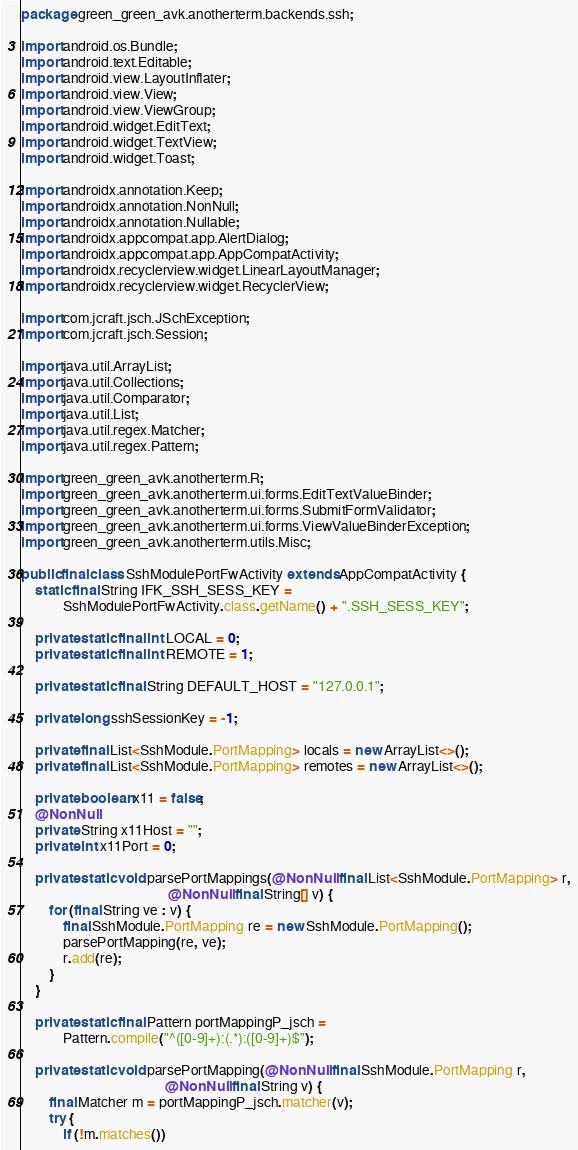<code> <loc_0><loc_0><loc_500><loc_500><_Java_>package green_green_avk.anotherterm.backends.ssh;

import android.os.Bundle;
import android.text.Editable;
import android.view.LayoutInflater;
import android.view.View;
import android.view.ViewGroup;
import android.widget.EditText;
import android.widget.TextView;
import android.widget.Toast;

import androidx.annotation.Keep;
import androidx.annotation.NonNull;
import androidx.annotation.Nullable;
import androidx.appcompat.app.AlertDialog;
import androidx.appcompat.app.AppCompatActivity;
import androidx.recyclerview.widget.LinearLayoutManager;
import androidx.recyclerview.widget.RecyclerView;

import com.jcraft.jsch.JSchException;
import com.jcraft.jsch.Session;

import java.util.ArrayList;
import java.util.Collections;
import java.util.Comparator;
import java.util.List;
import java.util.regex.Matcher;
import java.util.regex.Pattern;

import green_green_avk.anotherterm.R;
import green_green_avk.anotherterm.ui.forms.EditTextValueBinder;
import green_green_avk.anotherterm.ui.forms.SubmitFormValidator;
import green_green_avk.anotherterm.ui.forms.ViewValueBinderException;
import green_green_avk.anotherterm.utils.Misc;

public final class SshModulePortFwActivity extends AppCompatActivity {
    static final String IFK_SSH_SESS_KEY =
            SshModulePortFwActivity.class.getName() + ".SSH_SESS_KEY";

    private static final int LOCAL = 0;
    private static final int REMOTE = 1;

    private static final String DEFAULT_HOST = "127.0.0.1";

    private long sshSessionKey = -1;

    private final List<SshModule.PortMapping> locals = new ArrayList<>();
    private final List<SshModule.PortMapping> remotes = new ArrayList<>();

    private boolean x11 = false;
    @NonNull
    private String x11Host = "";
    private int x11Port = 0;

    private static void parsePortMappings(@NonNull final List<SshModule.PortMapping> r,
                                          @NonNull final String[] v) {
        for (final String ve : v) {
            final SshModule.PortMapping re = new SshModule.PortMapping();
            parsePortMapping(re, ve);
            r.add(re);
        }
    }

    private static final Pattern portMappingP_jsch =
            Pattern.compile("^([0-9]+):(.*):([0-9]+)$");

    private static void parsePortMapping(@NonNull final SshModule.PortMapping r,
                                         @NonNull final String v) {
        final Matcher m = portMappingP_jsch.matcher(v);
        try {
            if (!m.matches())</code> 